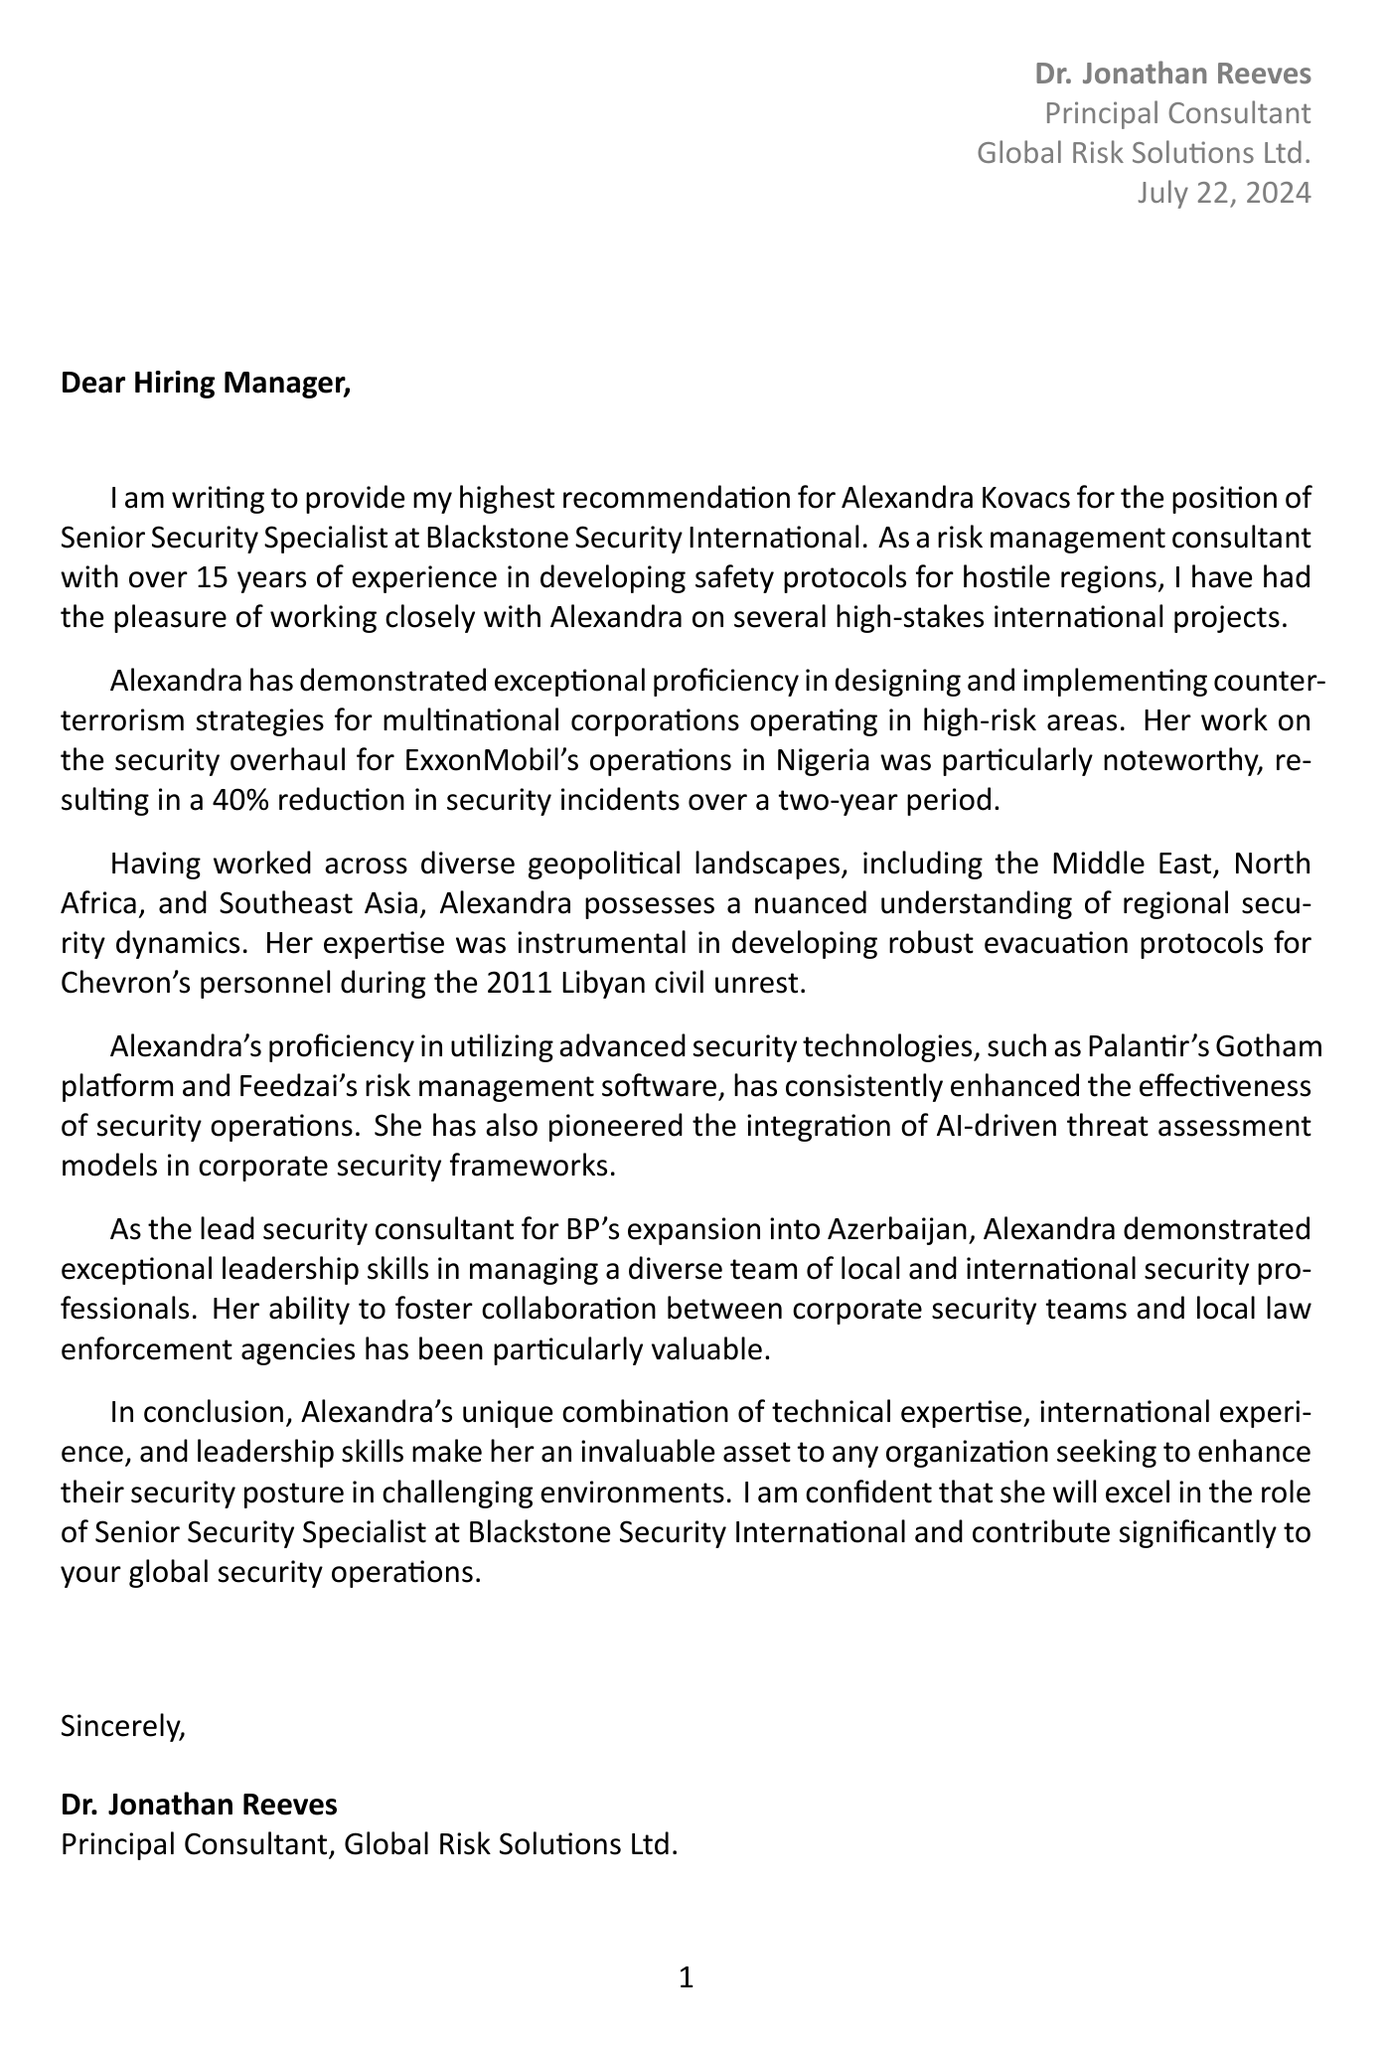What is the candidate's name? The candidate's name is provided in the opening paragraph of the letter.
Answer: Alexandra Kovacs What is the position being applied for? The position for which the candidate is being recommended is mentioned prominently in the letter.
Answer: Senior Security Specialist How many years of experience does the candidate have? The number of years of experience is noted in the candidate details section.
Answer: 12 What notable award did the candidate receive? The award received by the candidate is stated in the candidate's achievements section.
Answer: 2019 ASIS International Award for Excellence in Global Security Which company did the candidate work for in Iraq? The company associated with the candidate's work in Iraq is specified in the body of the letter.
Answer: Royal Dutch Shell What was the outcome of the security overhaul for ExxonMobil in Nigeria? The outcome of the project is quantified in the document.
Answer: 40% reduction in security incidents What advanced technology platforms is the candidate proficient in? The technologies utilized by the candidate are outlined in the technical skills section.
Answer: Palantir Gotham platform and Feedzai risk management software In which geographical locations has the candidate worked? The specific regions are listed in the body of the letter.
Answer: Middle East, North Africa, and Southeast Asia Who is writing the letter of recommendation? The name of the person providing the recommendation is provided at the end of the letter.
Answer: Dr. Jonathan Reeves 